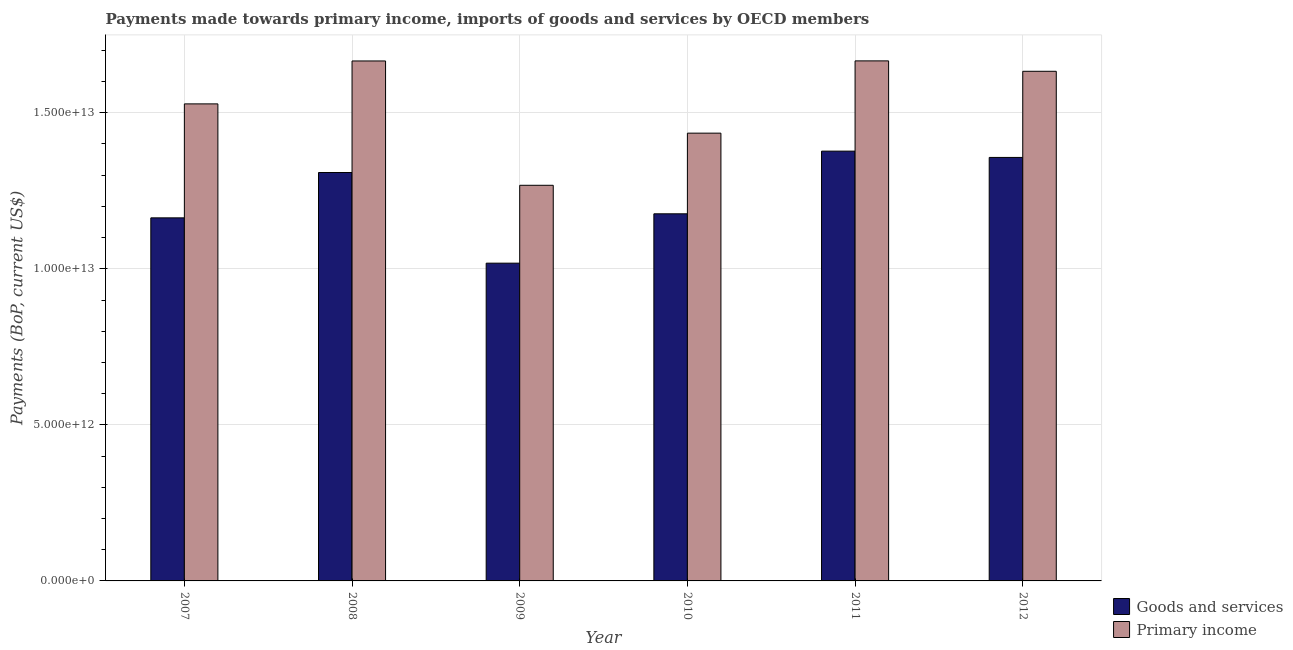How many different coloured bars are there?
Offer a very short reply. 2. Are the number of bars on each tick of the X-axis equal?
Offer a terse response. Yes. How many bars are there on the 3rd tick from the left?
Your response must be concise. 2. What is the label of the 1st group of bars from the left?
Your answer should be compact. 2007. What is the payments made towards primary income in 2010?
Your response must be concise. 1.43e+13. Across all years, what is the maximum payments made towards goods and services?
Make the answer very short. 1.38e+13. Across all years, what is the minimum payments made towards primary income?
Provide a succinct answer. 1.27e+13. In which year was the payments made towards goods and services maximum?
Offer a very short reply. 2011. In which year was the payments made towards primary income minimum?
Give a very brief answer. 2009. What is the total payments made towards goods and services in the graph?
Offer a very short reply. 7.40e+13. What is the difference between the payments made towards goods and services in 2008 and that in 2012?
Offer a terse response. -4.83e+11. What is the difference between the payments made towards primary income in 2011 and the payments made towards goods and services in 2007?
Your answer should be very brief. 1.38e+12. What is the average payments made towards primary income per year?
Offer a terse response. 1.53e+13. In how many years, is the payments made towards primary income greater than 9000000000000 US$?
Provide a short and direct response. 6. What is the ratio of the payments made towards primary income in 2008 to that in 2010?
Offer a terse response. 1.16. What is the difference between the highest and the second highest payments made towards goods and services?
Your answer should be compact. 2.02e+11. What is the difference between the highest and the lowest payments made towards goods and services?
Provide a short and direct response. 3.59e+12. What does the 1st bar from the left in 2011 represents?
Your response must be concise. Goods and services. What does the 1st bar from the right in 2007 represents?
Keep it short and to the point. Primary income. How many bars are there?
Your response must be concise. 12. Are all the bars in the graph horizontal?
Ensure brevity in your answer.  No. How many years are there in the graph?
Offer a very short reply. 6. What is the difference between two consecutive major ticks on the Y-axis?
Your answer should be compact. 5.00e+12. Are the values on the major ticks of Y-axis written in scientific E-notation?
Your answer should be compact. Yes. Where does the legend appear in the graph?
Your answer should be very brief. Bottom right. How many legend labels are there?
Your answer should be very brief. 2. What is the title of the graph?
Make the answer very short. Payments made towards primary income, imports of goods and services by OECD members. What is the label or title of the X-axis?
Your answer should be compact. Year. What is the label or title of the Y-axis?
Your answer should be very brief. Payments (BoP, current US$). What is the Payments (BoP, current US$) of Goods and services in 2007?
Offer a terse response. 1.16e+13. What is the Payments (BoP, current US$) of Primary income in 2007?
Provide a succinct answer. 1.53e+13. What is the Payments (BoP, current US$) of Goods and services in 2008?
Make the answer very short. 1.31e+13. What is the Payments (BoP, current US$) of Primary income in 2008?
Your answer should be compact. 1.67e+13. What is the Payments (BoP, current US$) in Goods and services in 2009?
Your response must be concise. 1.02e+13. What is the Payments (BoP, current US$) in Primary income in 2009?
Ensure brevity in your answer.  1.27e+13. What is the Payments (BoP, current US$) of Goods and services in 2010?
Offer a terse response. 1.18e+13. What is the Payments (BoP, current US$) in Primary income in 2010?
Provide a succinct answer. 1.43e+13. What is the Payments (BoP, current US$) of Goods and services in 2011?
Your answer should be very brief. 1.38e+13. What is the Payments (BoP, current US$) in Primary income in 2011?
Provide a short and direct response. 1.67e+13. What is the Payments (BoP, current US$) of Goods and services in 2012?
Keep it short and to the point. 1.36e+13. What is the Payments (BoP, current US$) in Primary income in 2012?
Keep it short and to the point. 1.63e+13. Across all years, what is the maximum Payments (BoP, current US$) in Goods and services?
Your answer should be very brief. 1.38e+13. Across all years, what is the maximum Payments (BoP, current US$) in Primary income?
Your answer should be very brief. 1.67e+13. Across all years, what is the minimum Payments (BoP, current US$) in Goods and services?
Your answer should be compact. 1.02e+13. Across all years, what is the minimum Payments (BoP, current US$) in Primary income?
Keep it short and to the point. 1.27e+13. What is the total Payments (BoP, current US$) in Goods and services in the graph?
Your response must be concise. 7.40e+13. What is the total Payments (BoP, current US$) of Primary income in the graph?
Your answer should be very brief. 9.20e+13. What is the difference between the Payments (BoP, current US$) in Goods and services in 2007 and that in 2008?
Give a very brief answer. -1.45e+12. What is the difference between the Payments (BoP, current US$) of Primary income in 2007 and that in 2008?
Your answer should be very brief. -1.38e+12. What is the difference between the Payments (BoP, current US$) of Goods and services in 2007 and that in 2009?
Offer a terse response. 1.45e+12. What is the difference between the Payments (BoP, current US$) in Primary income in 2007 and that in 2009?
Provide a succinct answer. 2.61e+12. What is the difference between the Payments (BoP, current US$) in Goods and services in 2007 and that in 2010?
Provide a succinct answer. -1.30e+11. What is the difference between the Payments (BoP, current US$) in Primary income in 2007 and that in 2010?
Keep it short and to the point. 9.38e+11. What is the difference between the Payments (BoP, current US$) of Goods and services in 2007 and that in 2011?
Your response must be concise. -2.14e+12. What is the difference between the Payments (BoP, current US$) of Primary income in 2007 and that in 2011?
Offer a terse response. -1.38e+12. What is the difference between the Payments (BoP, current US$) of Goods and services in 2007 and that in 2012?
Make the answer very short. -1.94e+12. What is the difference between the Payments (BoP, current US$) in Primary income in 2007 and that in 2012?
Your answer should be very brief. -1.04e+12. What is the difference between the Payments (BoP, current US$) in Goods and services in 2008 and that in 2009?
Provide a succinct answer. 2.90e+12. What is the difference between the Payments (BoP, current US$) of Primary income in 2008 and that in 2009?
Give a very brief answer. 3.98e+12. What is the difference between the Payments (BoP, current US$) in Goods and services in 2008 and that in 2010?
Your response must be concise. 1.32e+12. What is the difference between the Payments (BoP, current US$) in Primary income in 2008 and that in 2010?
Give a very brief answer. 2.31e+12. What is the difference between the Payments (BoP, current US$) in Goods and services in 2008 and that in 2011?
Keep it short and to the point. -6.85e+11. What is the difference between the Payments (BoP, current US$) in Primary income in 2008 and that in 2011?
Make the answer very short. -2.55e+09. What is the difference between the Payments (BoP, current US$) of Goods and services in 2008 and that in 2012?
Keep it short and to the point. -4.83e+11. What is the difference between the Payments (BoP, current US$) of Primary income in 2008 and that in 2012?
Your answer should be very brief. 3.31e+11. What is the difference between the Payments (BoP, current US$) in Goods and services in 2009 and that in 2010?
Keep it short and to the point. -1.58e+12. What is the difference between the Payments (BoP, current US$) of Primary income in 2009 and that in 2010?
Offer a very short reply. -1.67e+12. What is the difference between the Payments (BoP, current US$) of Goods and services in 2009 and that in 2011?
Keep it short and to the point. -3.59e+12. What is the difference between the Payments (BoP, current US$) of Primary income in 2009 and that in 2011?
Your response must be concise. -3.99e+12. What is the difference between the Payments (BoP, current US$) in Goods and services in 2009 and that in 2012?
Offer a very short reply. -3.39e+12. What is the difference between the Payments (BoP, current US$) of Primary income in 2009 and that in 2012?
Offer a terse response. -3.65e+12. What is the difference between the Payments (BoP, current US$) of Goods and services in 2010 and that in 2011?
Ensure brevity in your answer.  -2.01e+12. What is the difference between the Payments (BoP, current US$) in Primary income in 2010 and that in 2011?
Provide a succinct answer. -2.32e+12. What is the difference between the Payments (BoP, current US$) of Goods and services in 2010 and that in 2012?
Provide a succinct answer. -1.81e+12. What is the difference between the Payments (BoP, current US$) of Primary income in 2010 and that in 2012?
Keep it short and to the point. -1.98e+12. What is the difference between the Payments (BoP, current US$) in Goods and services in 2011 and that in 2012?
Your answer should be very brief. 2.02e+11. What is the difference between the Payments (BoP, current US$) of Primary income in 2011 and that in 2012?
Your answer should be compact. 3.34e+11. What is the difference between the Payments (BoP, current US$) in Goods and services in 2007 and the Payments (BoP, current US$) in Primary income in 2008?
Your answer should be compact. -5.03e+12. What is the difference between the Payments (BoP, current US$) of Goods and services in 2007 and the Payments (BoP, current US$) of Primary income in 2009?
Offer a very short reply. -1.04e+12. What is the difference between the Payments (BoP, current US$) in Goods and services in 2007 and the Payments (BoP, current US$) in Primary income in 2010?
Your answer should be compact. -2.71e+12. What is the difference between the Payments (BoP, current US$) of Goods and services in 2007 and the Payments (BoP, current US$) of Primary income in 2011?
Your answer should be compact. -5.03e+12. What is the difference between the Payments (BoP, current US$) of Goods and services in 2007 and the Payments (BoP, current US$) of Primary income in 2012?
Offer a very short reply. -4.70e+12. What is the difference between the Payments (BoP, current US$) in Goods and services in 2008 and the Payments (BoP, current US$) in Primary income in 2009?
Your response must be concise. 4.09e+11. What is the difference between the Payments (BoP, current US$) of Goods and services in 2008 and the Payments (BoP, current US$) of Primary income in 2010?
Your answer should be very brief. -1.26e+12. What is the difference between the Payments (BoP, current US$) in Goods and services in 2008 and the Payments (BoP, current US$) in Primary income in 2011?
Keep it short and to the point. -3.58e+12. What is the difference between the Payments (BoP, current US$) in Goods and services in 2008 and the Payments (BoP, current US$) in Primary income in 2012?
Offer a very short reply. -3.24e+12. What is the difference between the Payments (BoP, current US$) in Goods and services in 2009 and the Payments (BoP, current US$) in Primary income in 2010?
Keep it short and to the point. -4.17e+12. What is the difference between the Payments (BoP, current US$) in Goods and services in 2009 and the Payments (BoP, current US$) in Primary income in 2011?
Your response must be concise. -6.48e+12. What is the difference between the Payments (BoP, current US$) of Goods and services in 2009 and the Payments (BoP, current US$) of Primary income in 2012?
Provide a succinct answer. -6.15e+12. What is the difference between the Payments (BoP, current US$) in Goods and services in 2010 and the Payments (BoP, current US$) in Primary income in 2011?
Give a very brief answer. -4.90e+12. What is the difference between the Payments (BoP, current US$) of Goods and services in 2010 and the Payments (BoP, current US$) of Primary income in 2012?
Make the answer very short. -4.57e+12. What is the difference between the Payments (BoP, current US$) of Goods and services in 2011 and the Payments (BoP, current US$) of Primary income in 2012?
Give a very brief answer. -2.56e+12. What is the average Payments (BoP, current US$) of Goods and services per year?
Make the answer very short. 1.23e+13. What is the average Payments (BoP, current US$) in Primary income per year?
Provide a short and direct response. 1.53e+13. In the year 2007, what is the difference between the Payments (BoP, current US$) in Goods and services and Payments (BoP, current US$) in Primary income?
Your answer should be compact. -3.65e+12. In the year 2008, what is the difference between the Payments (BoP, current US$) of Goods and services and Payments (BoP, current US$) of Primary income?
Offer a very short reply. -3.57e+12. In the year 2009, what is the difference between the Payments (BoP, current US$) in Goods and services and Payments (BoP, current US$) in Primary income?
Provide a succinct answer. -2.50e+12. In the year 2010, what is the difference between the Payments (BoP, current US$) of Goods and services and Payments (BoP, current US$) of Primary income?
Ensure brevity in your answer.  -2.58e+12. In the year 2011, what is the difference between the Payments (BoP, current US$) in Goods and services and Payments (BoP, current US$) in Primary income?
Give a very brief answer. -2.89e+12. In the year 2012, what is the difference between the Payments (BoP, current US$) of Goods and services and Payments (BoP, current US$) of Primary income?
Make the answer very short. -2.76e+12. What is the ratio of the Payments (BoP, current US$) of Goods and services in 2007 to that in 2008?
Offer a terse response. 0.89. What is the ratio of the Payments (BoP, current US$) in Primary income in 2007 to that in 2008?
Offer a very short reply. 0.92. What is the ratio of the Payments (BoP, current US$) in Goods and services in 2007 to that in 2009?
Provide a succinct answer. 1.14. What is the ratio of the Payments (BoP, current US$) of Primary income in 2007 to that in 2009?
Provide a short and direct response. 1.21. What is the ratio of the Payments (BoP, current US$) in Goods and services in 2007 to that in 2010?
Make the answer very short. 0.99. What is the ratio of the Payments (BoP, current US$) of Primary income in 2007 to that in 2010?
Provide a succinct answer. 1.07. What is the ratio of the Payments (BoP, current US$) of Goods and services in 2007 to that in 2011?
Provide a short and direct response. 0.84. What is the ratio of the Payments (BoP, current US$) of Primary income in 2007 to that in 2011?
Provide a succinct answer. 0.92. What is the ratio of the Payments (BoP, current US$) of Goods and services in 2007 to that in 2012?
Your answer should be compact. 0.86. What is the ratio of the Payments (BoP, current US$) in Primary income in 2007 to that in 2012?
Your answer should be compact. 0.94. What is the ratio of the Payments (BoP, current US$) in Goods and services in 2008 to that in 2009?
Ensure brevity in your answer.  1.29. What is the ratio of the Payments (BoP, current US$) of Primary income in 2008 to that in 2009?
Offer a very short reply. 1.31. What is the ratio of the Payments (BoP, current US$) of Goods and services in 2008 to that in 2010?
Give a very brief answer. 1.11. What is the ratio of the Payments (BoP, current US$) in Primary income in 2008 to that in 2010?
Provide a short and direct response. 1.16. What is the ratio of the Payments (BoP, current US$) of Goods and services in 2008 to that in 2011?
Your response must be concise. 0.95. What is the ratio of the Payments (BoP, current US$) in Goods and services in 2008 to that in 2012?
Your answer should be compact. 0.96. What is the ratio of the Payments (BoP, current US$) of Primary income in 2008 to that in 2012?
Offer a very short reply. 1.02. What is the ratio of the Payments (BoP, current US$) of Goods and services in 2009 to that in 2010?
Offer a very short reply. 0.87. What is the ratio of the Payments (BoP, current US$) of Primary income in 2009 to that in 2010?
Provide a short and direct response. 0.88. What is the ratio of the Payments (BoP, current US$) in Goods and services in 2009 to that in 2011?
Give a very brief answer. 0.74. What is the ratio of the Payments (BoP, current US$) in Primary income in 2009 to that in 2011?
Make the answer very short. 0.76. What is the ratio of the Payments (BoP, current US$) in Goods and services in 2009 to that in 2012?
Make the answer very short. 0.75. What is the ratio of the Payments (BoP, current US$) of Primary income in 2009 to that in 2012?
Your answer should be compact. 0.78. What is the ratio of the Payments (BoP, current US$) in Goods and services in 2010 to that in 2011?
Your answer should be compact. 0.85. What is the ratio of the Payments (BoP, current US$) of Primary income in 2010 to that in 2011?
Keep it short and to the point. 0.86. What is the ratio of the Payments (BoP, current US$) in Goods and services in 2010 to that in 2012?
Your answer should be very brief. 0.87. What is the ratio of the Payments (BoP, current US$) in Primary income in 2010 to that in 2012?
Keep it short and to the point. 0.88. What is the ratio of the Payments (BoP, current US$) in Goods and services in 2011 to that in 2012?
Offer a very short reply. 1.01. What is the ratio of the Payments (BoP, current US$) in Primary income in 2011 to that in 2012?
Provide a short and direct response. 1.02. What is the difference between the highest and the second highest Payments (BoP, current US$) of Goods and services?
Provide a short and direct response. 2.02e+11. What is the difference between the highest and the second highest Payments (BoP, current US$) in Primary income?
Offer a terse response. 2.55e+09. What is the difference between the highest and the lowest Payments (BoP, current US$) of Goods and services?
Offer a very short reply. 3.59e+12. What is the difference between the highest and the lowest Payments (BoP, current US$) in Primary income?
Provide a short and direct response. 3.99e+12. 